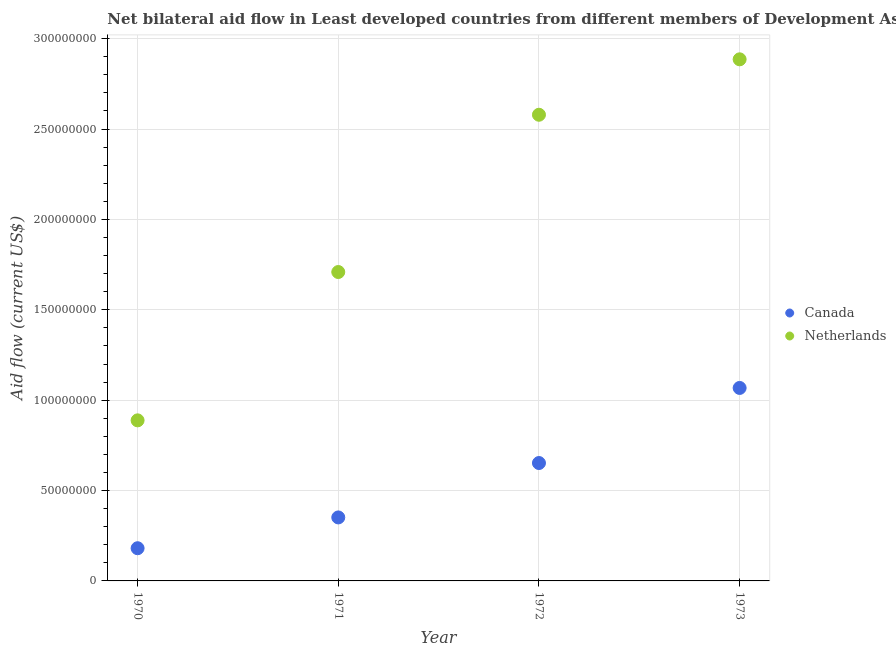What is the amount of aid given by canada in 1970?
Give a very brief answer. 1.81e+07. Across all years, what is the maximum amount of aid given by netherlands?
Offer a very short reply. 2.89e+08. Across all years, what is the minimum amount of aid given by netherlands?
Your answer should be compact. 8.88e+07. In which year was the amount of aid given by netherlands maximum?
Your response must be concise. 1973. What is the total amount of aid given by netherlands in the graph?
Your answer should be compact. 8.06e+08. What is the difference between the amount of aid given by netherlands in 1970 and that in 1973?
Your answer should be compact. -2.00e+08. What is the difference between the amount of aid given by netherlands in 1972 and the amount of aid given by canada in 1971?
Keep it short and to the point. 2.23e+08. What is the average amount of aid given by netherlands per year?
Your answer should be very brief. 2.02e+08. In the year 1971, what is the difference between the amount of aid given by netherlands and amount of aid given by canada?
Offer a terse response. 1.36e+08. What is the ratio of the amount of aid given by netherlands in 1970 to that in 1972?
Your answer should be very brief. 0.34. Is the amount of aid given by canada in 1971 less than that in 1973?
Keep it short and to the point. Yes. What is the difference between the highest and the second highest amount of aid given by canada?
Your answer should be compact. 4.15e+07. What is the difference between the highest and the lowest amount of aid given by canada?
Keep it short and to the point. 8.87e+07. In how many years, is the amount of aid given by canada greater than the average amount of aid given by canada taken over all years?
Ensure brevity in your answer.  2. Is the sum of the amount of aid given by canada in 1971 and 1972 greater than the maximum amount of aid given by netherlands across all years?
Your response must be concise. No. How many years are there in the graph?
Keep it short and to the point. 4. Does the graph contain any zero values?
Keep it short and to the point. No. Where does the legend appear in the graph?
Offer a terse response. Center right. How many legend labels are there?
Your answer should be very brief. 2. How are the legend labels stacked?
Ensure brevity in your answer.  Vertical. What is the title of the graph?
Your response must be concise. Net bilateral aid flow in Least developed countries from different members of Development Assistance Committee. Does "State government" appear as one of the legend labels in the graph?
Ensure brevity in your answer.  No. What is the label or title of the X-axis?
Offer a terse response. Year. What is the Aid flow (current US$) of Canada in 1970?
Your answer should be very brief. 1.81e+07. What is the Aid flow (current US$) in Netherlands in 1970?
Give a very brief answer. 8.88e+07. What is the Aid flow (current US$) in Canada in 1971?
Your response must be concise. 3.51e+07. What is the Aid flow (current US$) of Netherlands in 1971?
Provide a short and direct response. 1.71e+08. What is the Aid flow (current US$) in Canada in 1972?
Make the answer very short. 6.52e+07. What is the Aid flow (current US$) in Netherlands in 1972?
Give a very brief answer. 2.58e+08. What is the Aid flow (current US$) of Canada in 1973?
Your answer should be compact. 1.07e+08. What is the Aid flow (current US$) of Netherlands in 1973?
Your answer should be very brief. 2.89e+08. Across all years, what is the maximum Aid flow (current US$) in Canada?
Offer a very short reply. 1.07e+08. Across all years, what is the maximum Aid flow (current US$) in Netherlands?
Give a very brief answer. 2.89e+08. Across all years, what is the minimum Aid flow (current US$) in Canada?
Give a very brief answer. 1.81e+07. Across all years, what is the minimum Aid flow (current US$) of Netherlands?
Provide a short and direct response. 8.88e+07. What is the total Aid flow (current US$) in Canada in the graph?
Your answer should be very brief. 2.25e+08. What is the total Aid flow (current US$) of Netherlands in the graph?
Your answer should be very brief. 8.06e+08. What is the difference between the Aid flow (current US$) of Canada in 1970 and that in 1971?
Provide a succinct answer. -1.70e+07. What is the difference between the Aid flow (current US$) in Netherlands in 1970 and that in 1971?
Provide a short and direct response. -8.21e+07. What is the difference between the Aid flow (current US$) in Canada in 1970 and that in 1972?
Offer a terse response. -4.71e+07. What is the difference between the Aid flow (current US$) of Netherlands in 1970 and that in 1972?
Ensure brevity in your answer.  -1.69e+08. What is the difference between the Aid flow (current US$) of Canada in 1970 and that in 1973?
Offer a terse response. -8.87e+07. What is the difference between the Aid flow (current US$) of Netherlands in 1970 and that in 1973?
Make the answer very short. -2.00e+08. What is the difference between the Aid flow (current US$) of Canada in 1971 and that in 1972?
Make the answer very short. -3.01e+07. What is the difference between the Aid flow (current US$) of Netherlands in 1971 and that in 1972?
Provide a short and direct response. -8.70e+07. What is the difference between the Aid flow (current US$) in Canada in 1971 and that in 1973?
Give a very brief answer. -7.16e+07. What is the difference between the Aid flow (current US$) in Netherlands in 1971 and that in 1973?
Provide a succinct answer. -1.18e+08. What is the difference between the Aid flow (current US$) in Canada in 1972 and that in 1973?
Your answer should be very brief. -4.15e+07. What is the difference between the Aid flow (current US$) of Netherlands in 1972 and that in 1973?
Your response must be concise. -3.07e+07. What is the difference between the Aid flow (current US$) in Canada in 1970 and the Aid flow (current US$) in Netherlands in 1971?
Keep it short and to the point. -1.53e+08. What is the difference between the Aid flow (current US$) in Canada in 1970 and the Aid flow (current US$) in Netherlands in 1972?
Give a very brief answer. -2.40e+08. What is the difference between the Aid flow (current US$) of Canada in 1970 and the Aid flow (current US$) of Netherlands in 1973?
Provide a short and direct response. -2.70e+08. What is the difference between the Aid flow (current US$) of Canada in 1971 and the Aid flow (current US$) of Netherlands in 1972?
Keep it short and to the point. -2.23e+08. What is the difference between the Aid flow (current US$) in Canada in 1971 and the Aid flow (current US$) in Netherlands in 1973?
Keep it short and to the point. -2.53e+08. What is the difference between the Aid flow (current US$) in Canada in 1972 and the Aid flow (current US$) in Netherlands in 1973?
Keep it short and to the point. -2.23e+08. What is the average Aid flow (current US$) of Canada per year?
Keep it short and to the point. 5.63e+07. What is the average Aid flow (current US$) of Netherlands per year?
Offer a very short reply. 2.02e+08. In the year 1970, what is the difference between the Aid flow (current US$) in Canada and Aid flow (current US$) in Netherlands?
Make the answer very short. -7.08e+07. In the year 1971, what is the difference between the Aid flow (current US$) of Canada and Aid flow (current US$) of Netherlands?
Ensure brevity in your answer.  -1.36e+08. In the year 1972, what is the difference between the Aid flow (current US$) of Canada and Aid flow (current US$) of Netherlands?
Your response must be concise. -1.93e+08. In the year 1973, what is the difference between the Aid flow (current US$) in Canada and Aid flow (current US$) in Netherlands?
Your answer should be very brief. -1.82e+08. What is the ratio of the Aid flow (current US$) of Canada in 1970 to that in 1971?
Offer a very short reply. 0.51. What is the ratio of the Aid flow (current US$) of Netherlands in 1970 to that in 1971?
Offer a terse response. 0.52. What is the ratio of the Aid flow (current US$) of Canada in 1970 to that in 1972?
Offer a terse response. 0.28. What is the ratio of the Aid flow (current US$) in Netherlands in 1970 to that in 1972?
Offer a very short reply. 0.34. What is the ratio of the Aid flow (current US$) of Canada in 1970 to that in 1973?
Offer a terse response. 0.17. What is the ratio of the Aid flow (current US$) of Netherlands in 1970 to that in 1973?
Offer a very short reply. 0.31. What is the ratio of the Aid flow (current US$) of Canada in 1971 to that in 1972?
Your response must be concise. 0.54. What is the ratio of the Aid flow (current US$) in Netherlands in 1971 to that in 1972?
Ensure brevity in your answer.  0.66. What is the ratio of the Aid flow (current US$) of Canada in 1971 to that in 1973?
Ensure brevity in your answer.  0.33. What is the ratio of the Aid flow (current US$) of Netherlands in 1971 to that in 1973?
Your response must be concise. 0.59. What is the ratio of the Aid flow (current US$) of Canada in 1972 to that in 1973?
Make the answer very short. 0.61. What is the ratio of the Aid flow (current US$) of Netherlands in 1972 to that in 1973?
Your response must be concise. 0.89. What is the difference between the highest and the second highest Aid flow (current US$) of Canada?
Give a very brief answer. 4.15e+07. What is the difference between the highest and the second highest Aid flow (current US$) in Netherlands?
Offer a terse response. 3.07e+07. What is the difference between the highest and the lowest Aid flow (current US$) of Canada?
Give a very brief answer. 8.87e+07. What is the difference between the highest and the lowest Aid flow (current US$) of Netherlands?
Your answer should be compact. 2.00e+08. 